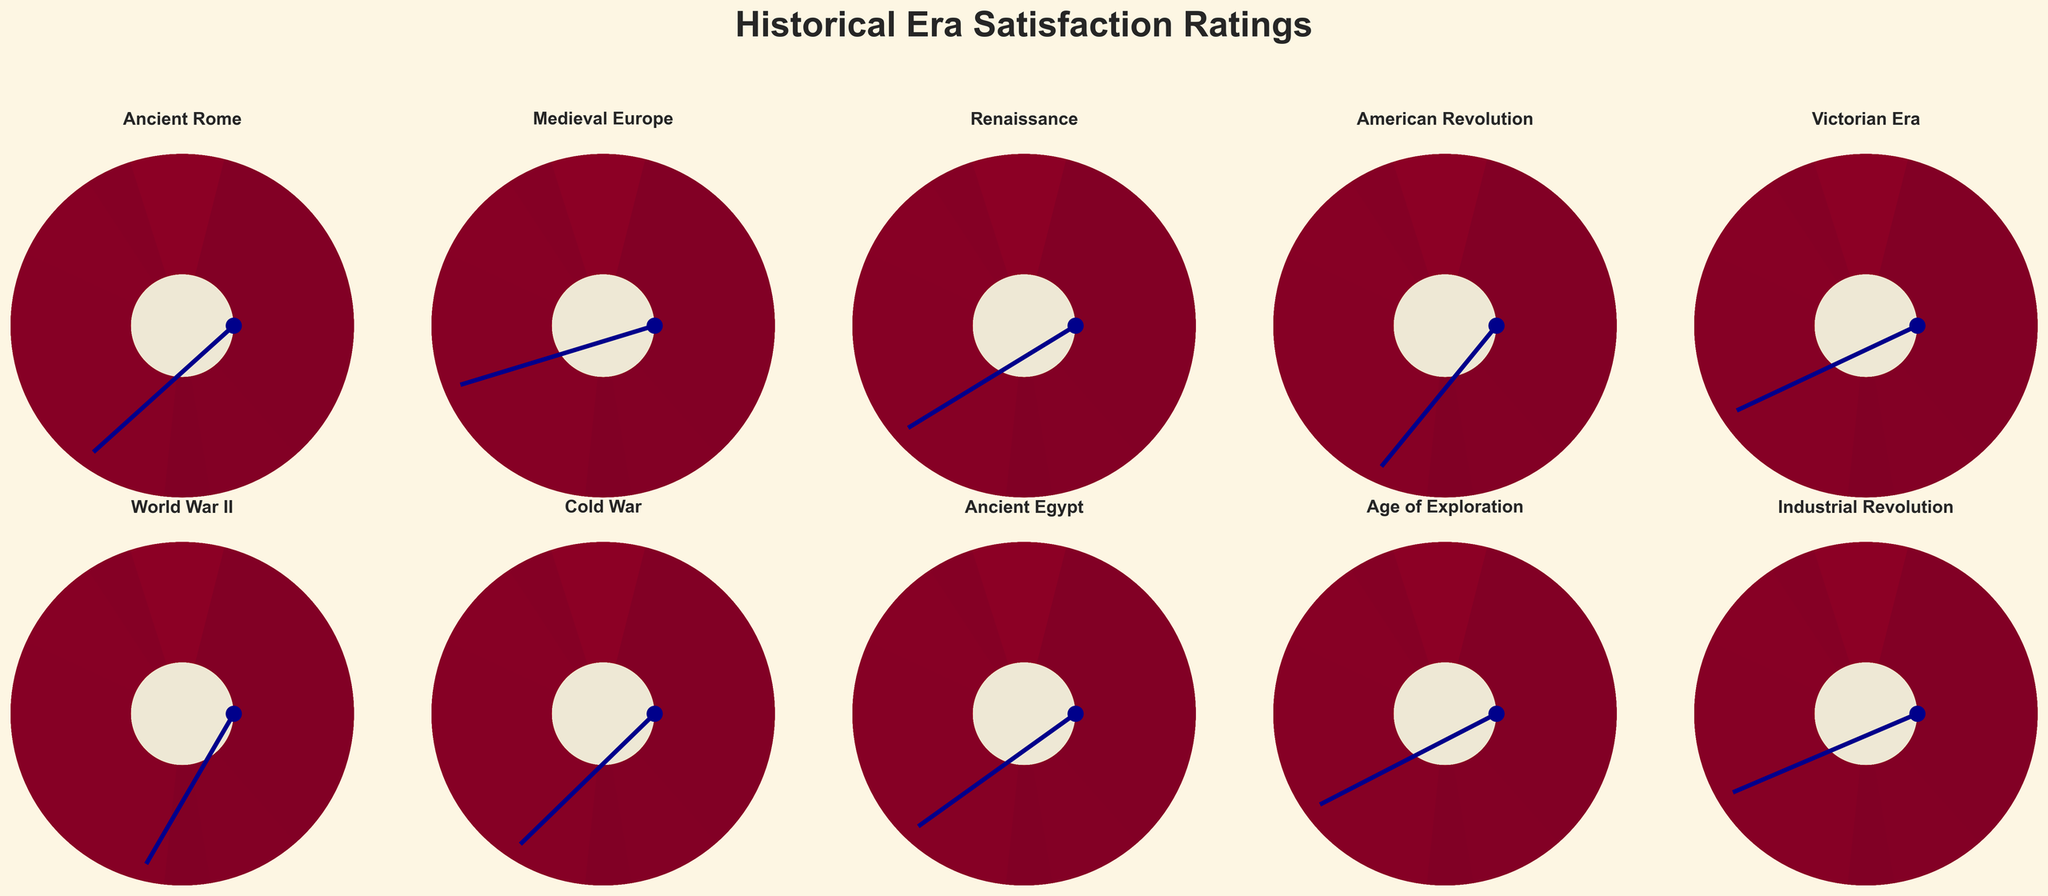Which era has the highest satisfaction rating? The needle on the World War II gauge is at 95%, which is the highest among all gauges.
Answer: World War II Which era has the lowest satisfaction rating? The Medieval Europe era has the lowest rating with the needle at 75%.
Answer: Medieval Europe How many eras have a satisfaction rating of 80% or higher? There are eight eras with satisfaction ratings of 80% or higher: Ancient Rome, Renaissance, American Revolution, Victorian Era, World War II, Cold War, Ancient Egypt, and Age of Exploration.
Answer: 8 What is the average satisfaction rating for all eras? Sum the satisfaction ratings: 87 + 75 + 82 + 91 + 79 + 95 + 88 + 84 + 80 + 78 = 839. Then divide by the number of eras (10): 839 / 10 = 83.9.
Answer: 83.9 Are there more eras with a satisfaction rating above 85% or below 85%? Eras with a rating above 85%: Ancient Rome, American Revolution, World War II, Cold War (4 eras). Eras with a rating below 85%: Medieval Europe, Renaissance, Victorian Era, Ancient Egypt, Age of Exploration, Industrial Revolution (6 eras).
Answer: Below 85% Which two eras have the closest satisfaction ratings? The Age of Exploration and the Industrial Revolution have ratings of 80% and 78%, respectively; the difference is only 2%.
Answer: Age of Exploration and Industrial Revolution What is the difference in satisfaction rating between the highest and lowest-rated eras? The highest rating is 95% (World War II) and the lowest is 75% (Medieval Europe). The difference is 95 - 75 = 20%.
Answer: 20% How does the satisfaction rating for the Cold War compare to the American Revolution? The Cold War has a satisfaction rating of 88%, while the American Revolution is at 91%. The Cold War rating is 3% lower than the American Revolution.
Answer: 3% lower Which era, Ancient Rome or Ancient Egypt, has a higher satisfaction rating and by how much? Ancient Rome has a satisfaction rating of 87% while Ancient Egypt has 84%. Ancient Rome's rating is 3% higher.
Answer: 3% higher What’s the median satisfaction rating for the historical eras? Arranging the ratings from lowest to highest: 75, 78, 79, 80, 82, 84, 87, 88, 91, 95. The middle values are 82 and 84, so the median is (82 + 84)/2 = 83.
Answer: 83 